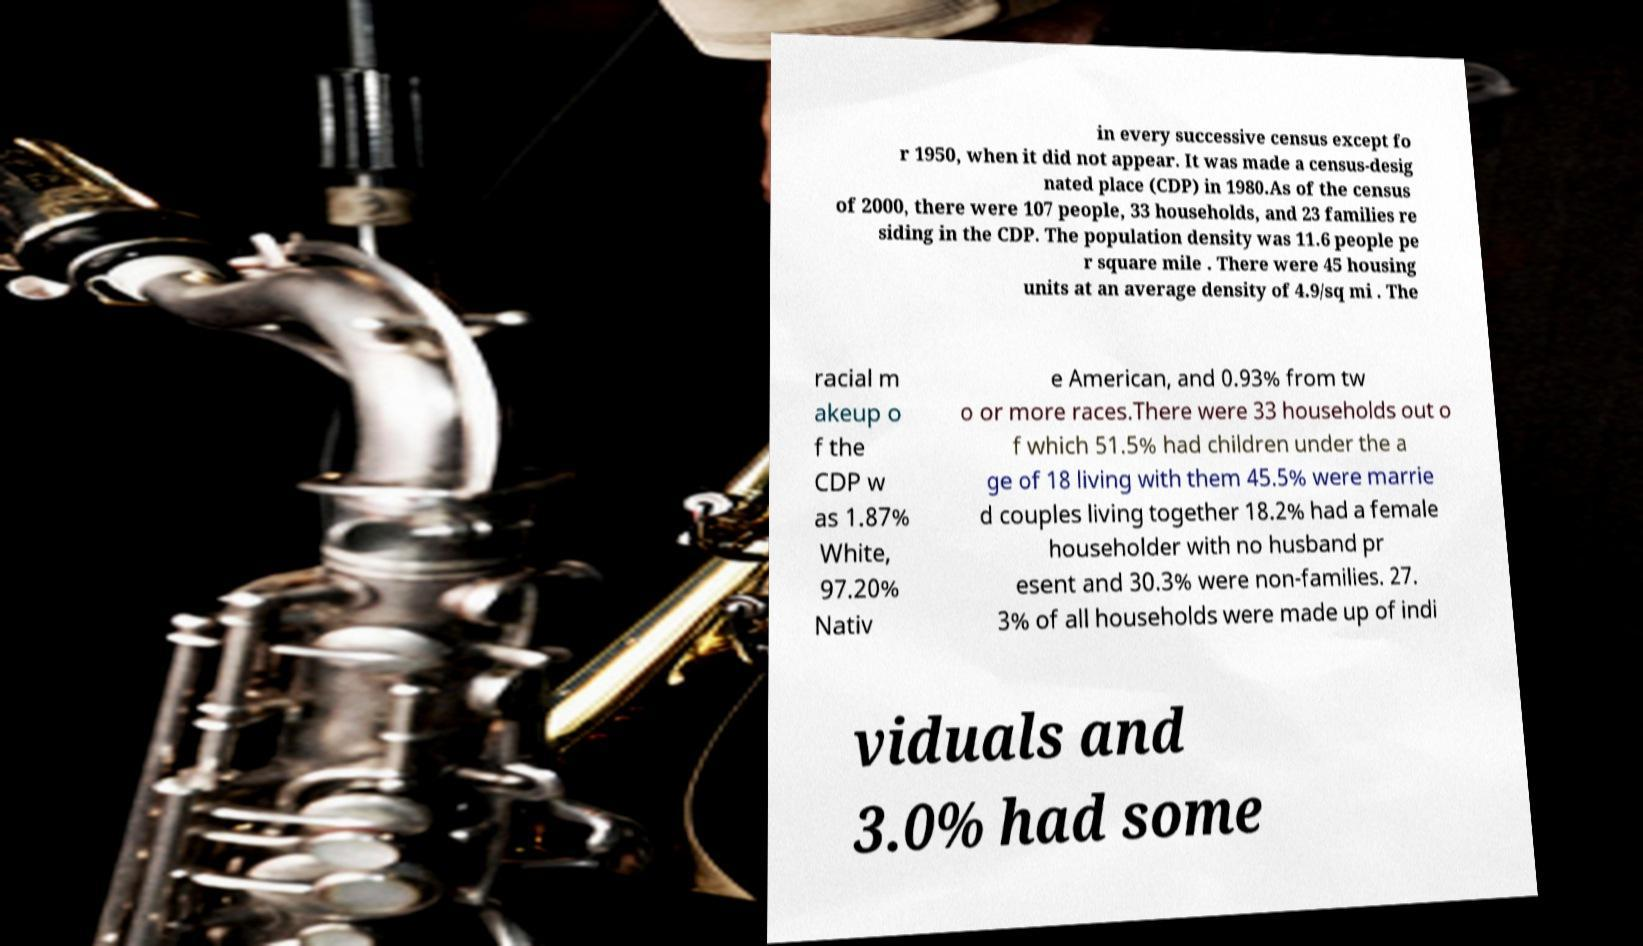Can you accurately transcribe the text from the provided image for me? in every successive census except fo r 1950, when it did not appear. It was made a census-desig nated place (CDP) in 1980.As of the census of 2000, there were 107 people, 33 households, and 23 families re siding in the CDP. The population density was 11.6 people pe r square mile . There were 45 housing units at an average density of 4.9/sq mi . The racial m akeup o f the CDP w as 1.87% White, 97.20% Nativ e American, and 0.93% from tw o or more races.There were 33 households out o f which 51.5% had children under the a ge of 18 living with them 45.5% were marrie d couples living together 18.2% had a female householder with no husband pr esent and 30.3% were non-families. 27. 3% of all households were made up of indi viduals and 3.0% had some 